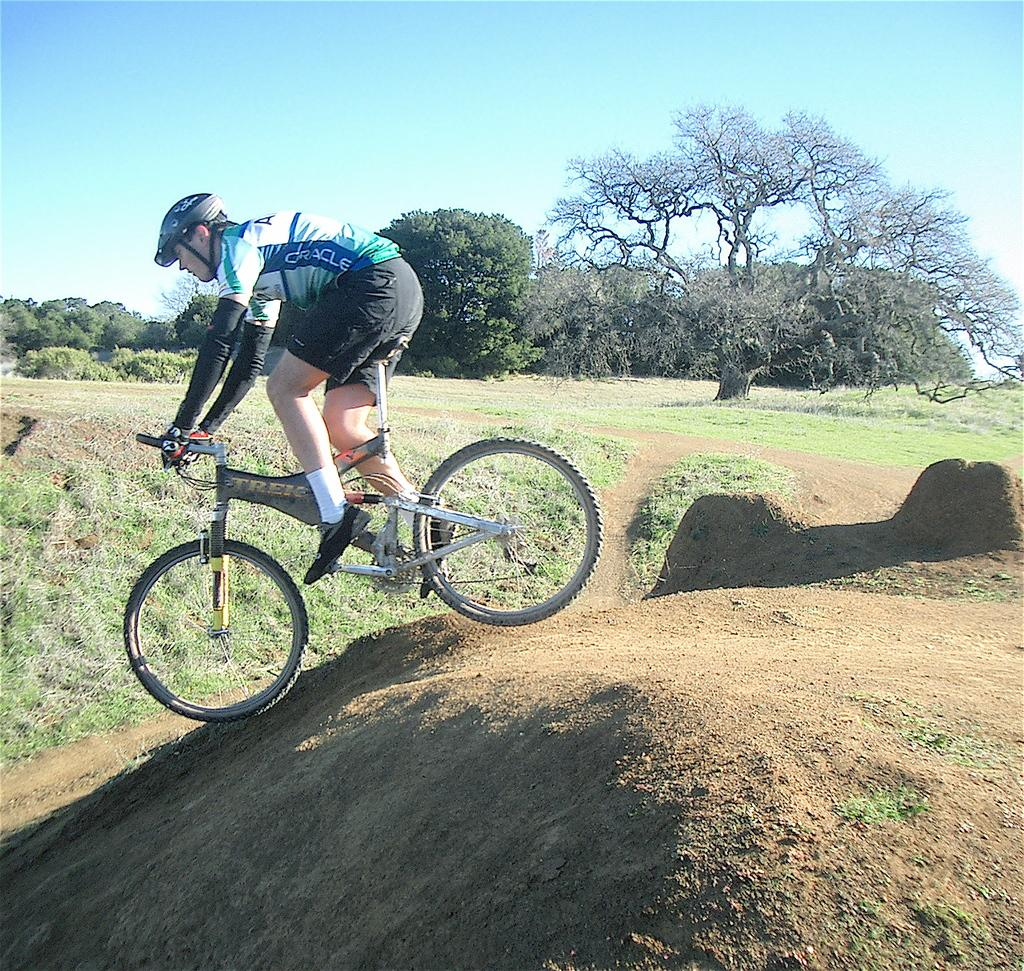Who is the person in the image? There is a man in the image. What is the man doing in the image? The man is riding a bicycle. Where is the bicycle located in the image? The bicycle is in the center of the image. What can be seen in the background of the image? There is grass on the ground and trees in the background. What type of space-related equipment can be seen in the image? There is no space-related equipment present in the image; it features a man riding a bicycle in a grassy area with trees in the background. 